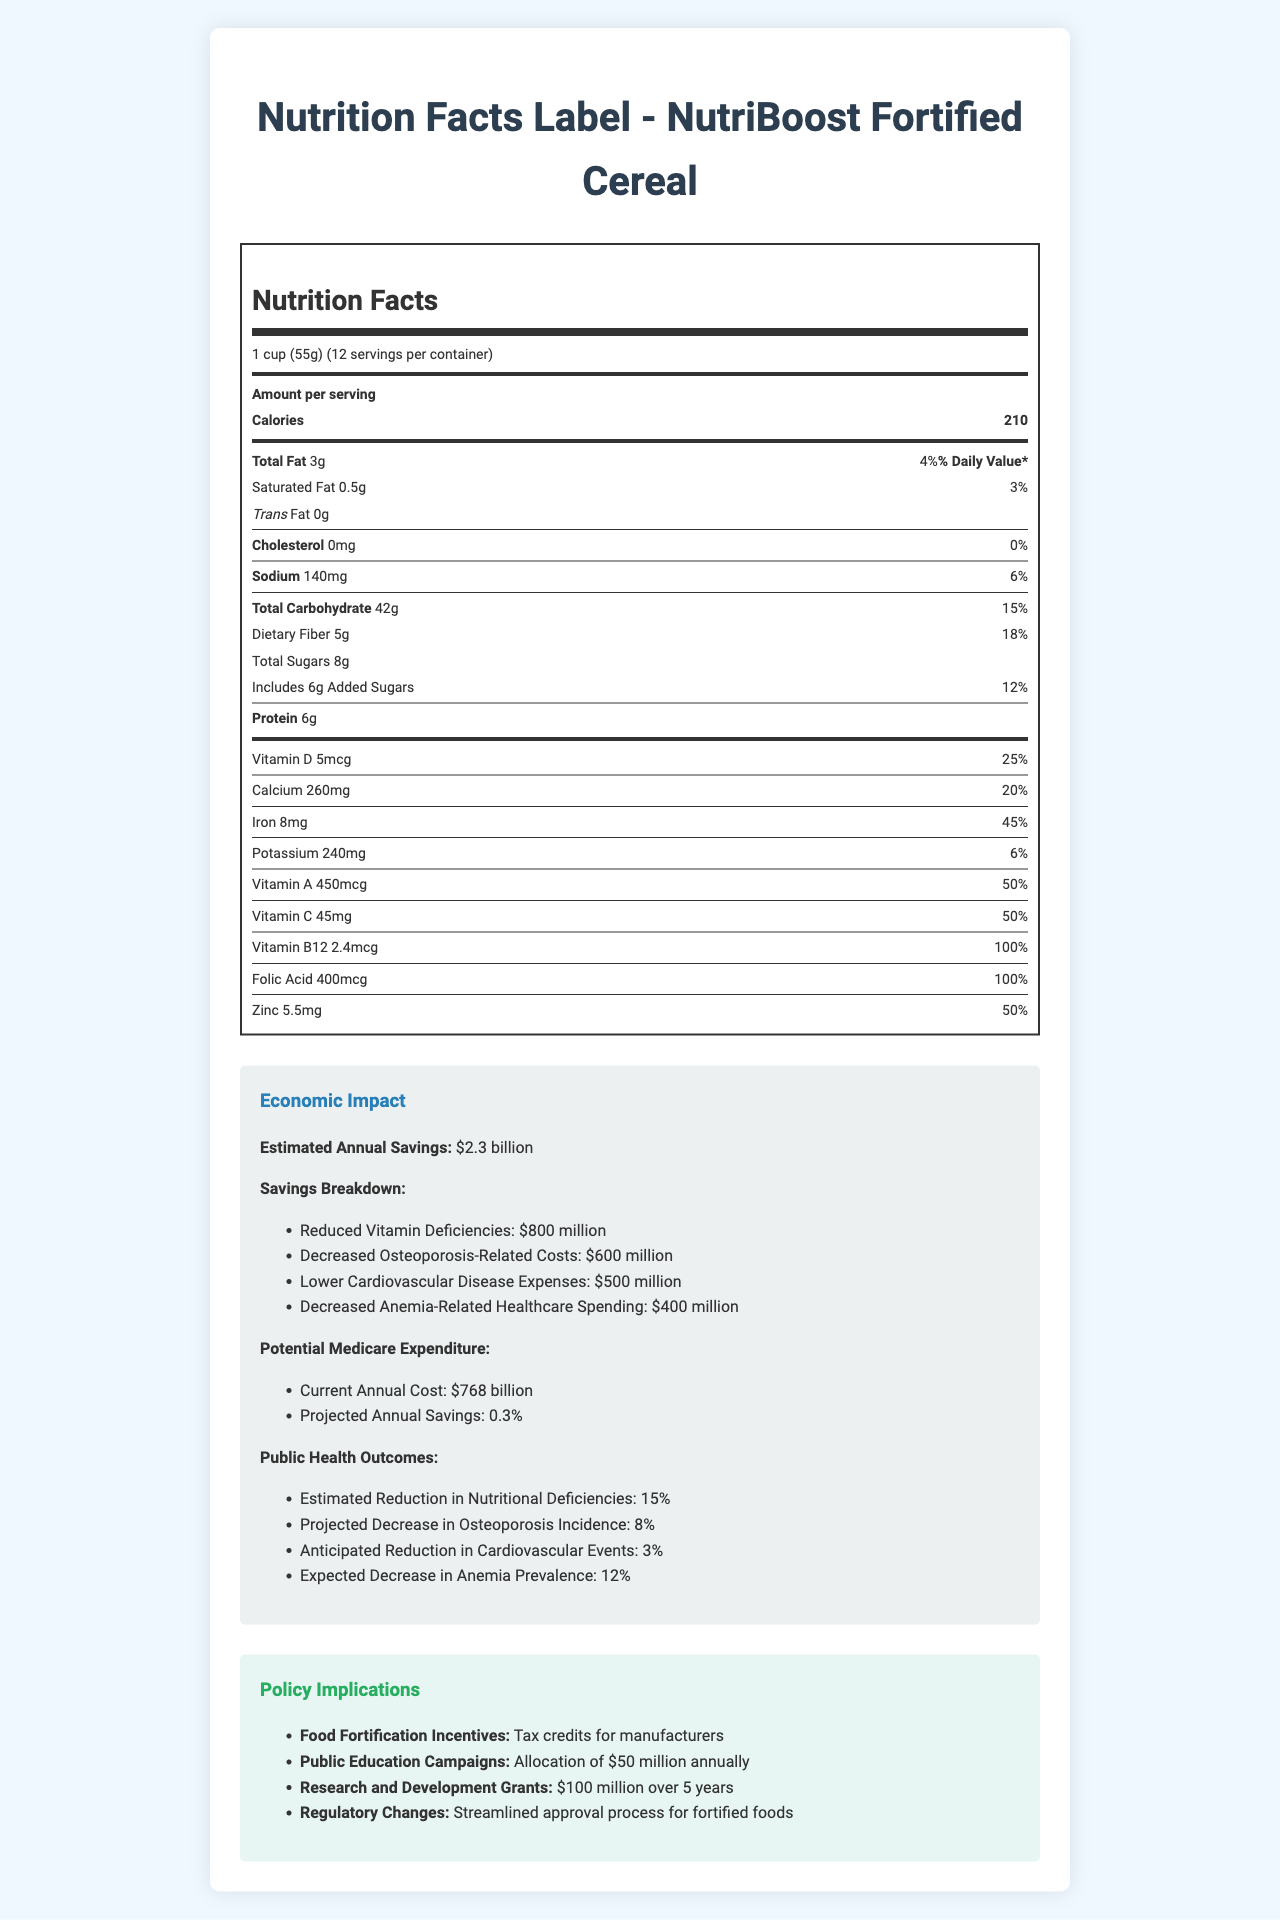what is the serving size for NutriBoost Fortified Cereal? The serving size is mentioned at the beginning of the Nutrition Facts Label.
Answer: 1 cup (55g) how many calories are there per serving? The number of calories per serving is stated as 210 in the Nutrition Facts section.
Answer: 210 what is the amount of dietary fiber per serving? The dietary fiber amount per serving is indicated as 5g on the Nutrition Facts Label.
Answer: 5g what percentage of the daily value of iron does one serving of the cereal provide? The daily value percentage for iron is given as 45% per serving.
Answer: 45% what vitamins and minerals does the cereal provide 100% of the daily value? The Nutrition Facts Label states that Vitamin B12 and Folic Acid both provide 100% of the daily value per serving.
Answer: Vitamin B12 and Folic Acid how much sodium is in a serving of the cereal? A. 140mg B. 260mg C. 240mg D. 1400mg The amount of sodium per serving is listed as 140mg in the Nutrition Facts Label.
Answer: A. 140mg which of the following nutrients is not present in the cereal? A. Trans Fat B. Cholesterol C. Total Sugars D. Protein Trans Fat is listed as 0g and Cholesterol is listed as 0mg, therefore Cholesterol is not present in the cereal.
Answer: B. Cholesterol does one serving of NutriBoost Fortified Cereal contain any trans fat? The Nutrition Facts Label clearly states that the amount of trans fat is 0g per serving.
Answer: No describe the economic impact section of the document The section outlines potential savings and health outcomes from improved nutrient intake due to the fortified cereal.
Answer: The economic impact section estimates annual savings of $2.3 billion due to NutriBoost Fortified Cereal. The savings are broken down into four categories: reduced vitamin deficiencies ($800 million), decreased osteoporosis-related costs ($600 million), lower cardiovascular disease expenses ($500 million), and decreased anemia-related healthcare spending ($400 million). It also predicts a 0.3% reduction in annual Medicare expenditures, translating to health improvements such as a 15% reduction in nutritional deficiencies, 8% decrease in osteoporosis incidence, 3% reduction in cardiovascular events, and 12% decrease in anemia prevalence. how many servings are there per container? The number of servings per container is listed as 12 in the Nutrition Facts Label.
Answer: 12 what is the estimated annual savings from reduced vitamin deficiencies? In the economic impact section, reduced vitamin deficiencies account for $800 million in savings.
Answer: $800 million how is the economic savings from decreased osteoporosis-related costs quantified? The economic impact section states that osteoporosis-related cost savings are estimated at $600 million.
Answer: $600 million what is the term used to describe the streamlining of the approval process for fortified foods? The policy implications section lists "Streamlined approval process for fortified foods" under Regulatory Changes.
Answer: Regulatory Changes how will incentives for food fortification be provided according to the document? The policy implications section mentions tax credits for manufacturers as an incentive for food fortification.
Answer: Tax credits for manufacturers how does the cereal impact public health outcomes regarding cardiovascular events? The economic impact section indicates a projected 3% reduction in cardiovascular events.
Answer: Anticipated Reduction in Cardiovascular Events: 3% what is the primary nutrient that the cereal does not contribute to the daily value percentage? The Nutrition Facts Label indicates that the cereal contains 0mg of cholesterol, contributing 0% to the daily value.
Answer: Cholesterol how much vitamin D does one serving of NutriBoost Fortified Cereal provide? The amount of vitamin D per serving is 5mcg on the Nutrition Facts Label.
Answer: 5mcg what is the estimated annual cost of current Medicare expenditure? The economic impact section mentions that the current annual cost for Medicare expenditure is $768 billion.
Answer: $768 billion can the exact ingredients of the cereal be determined from the document? The document provides nutritional information but does not list the specific ingredients.
Answer: Cannot be determined 